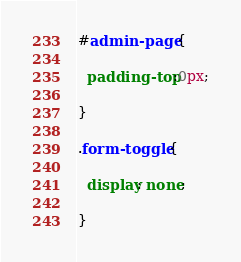Convert code to text. <code><loc_0><loc_0><loc_500><loc_500><_CSS_>#admin-page {

  padding-top:0px;

}

.form-toggle {

  display: none;

}</code> 